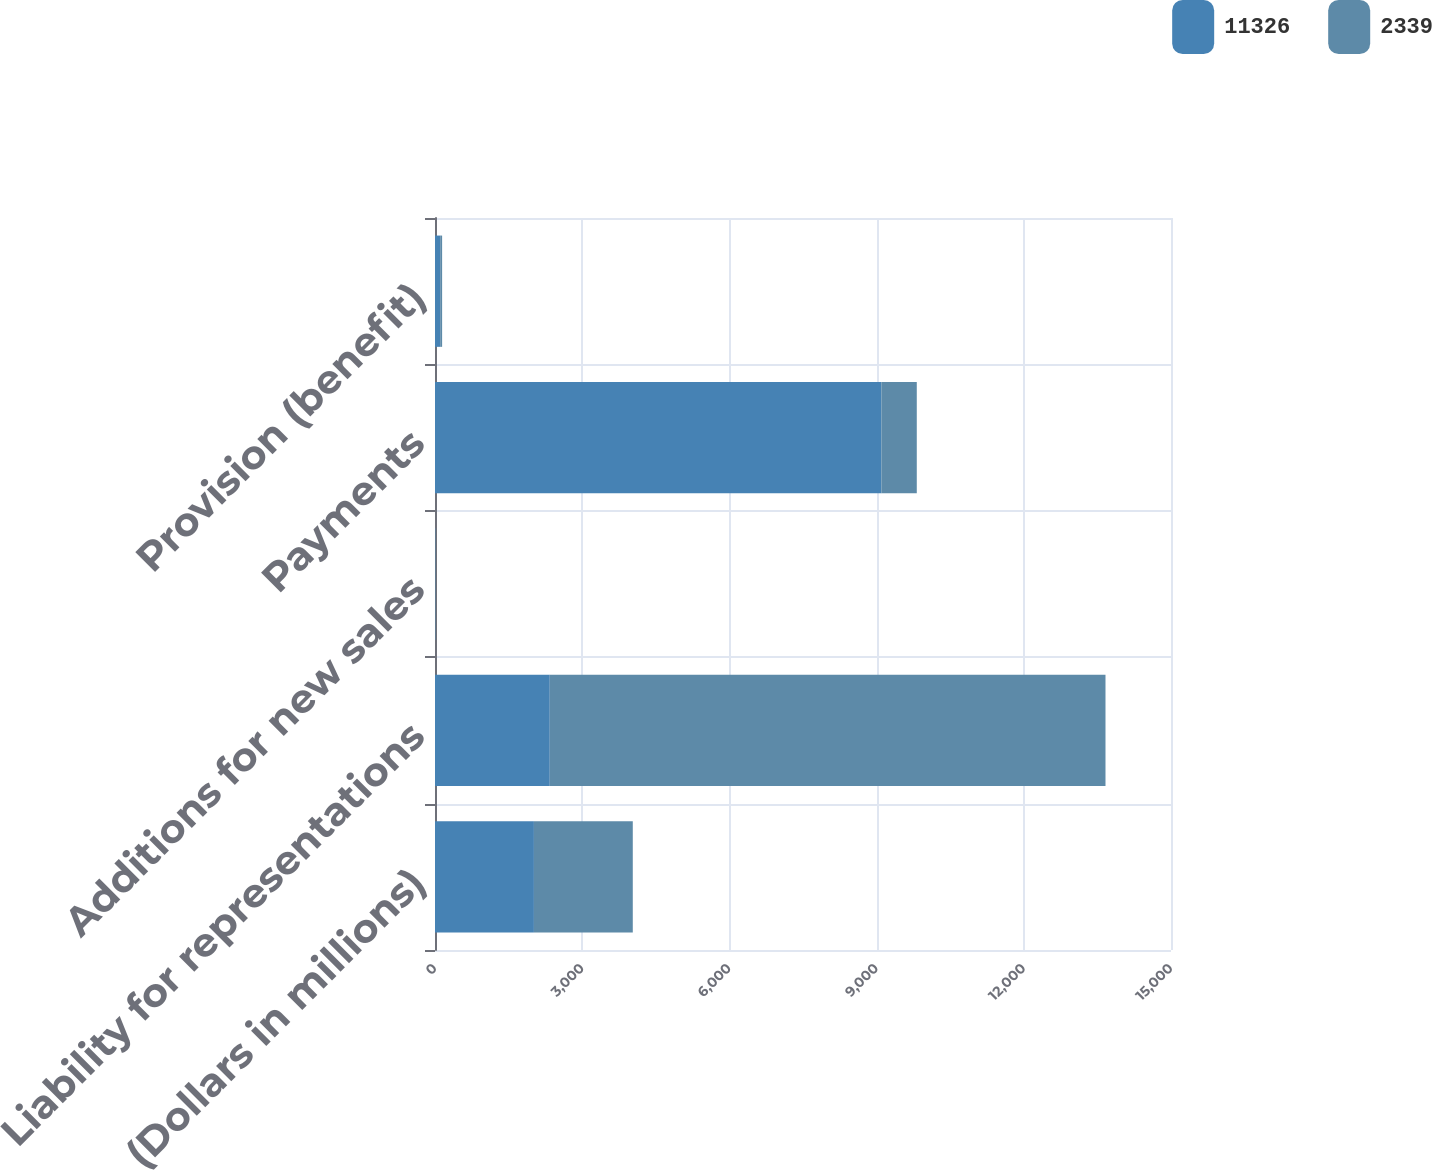Convert chart to OTSL. <chart><loc_0><loc_0><loc_500><loc_500><stacked_bar_chart><ecel><fcel>(Dollars in millions)<fcel>Liability for representations<fcel>Additions for new sales<fcel>Payments<fcel>Provision (benefit)<nl><fcel>11326<fcel>2016<fcel>2339<fcel>4<fcel>9097<fcel>106<nl><fcel>2339<fcel>2015<fcel>11326<fcel>6<fcel>722<fcel>39<nl></chart> 